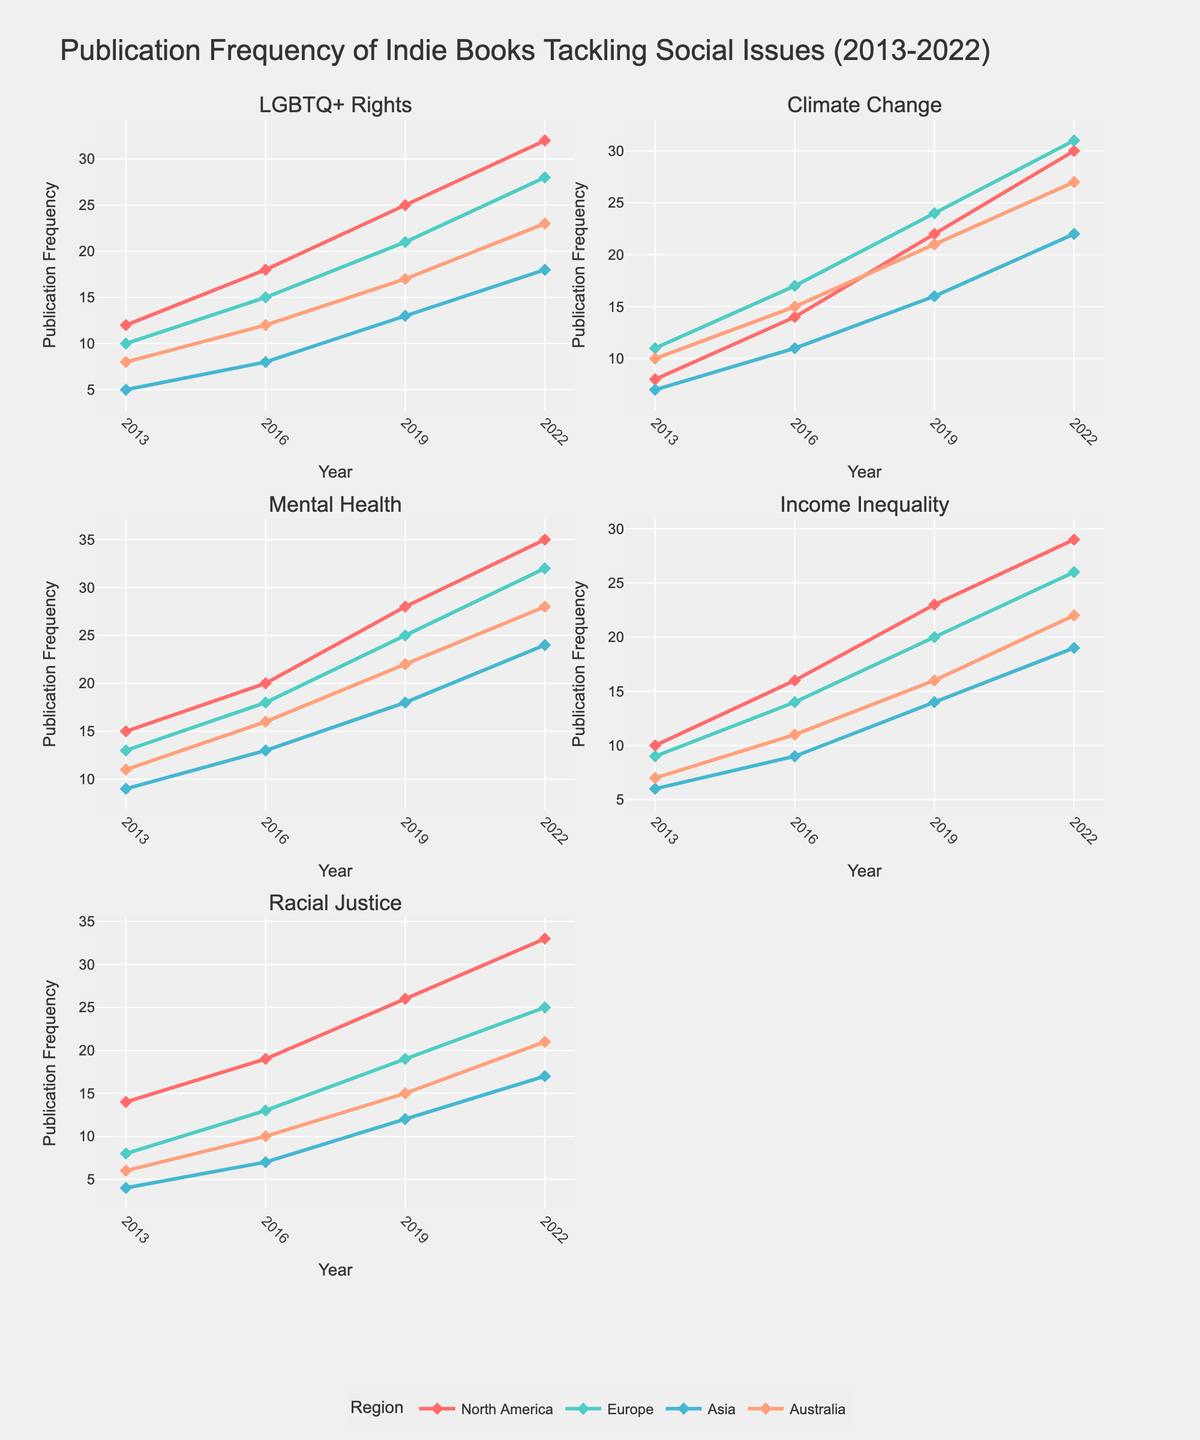What is the title of the figure? The title of the figure is typically located at the top of the visualization and is a text element summarizing the content or purpose. In this case, we can see "Publication Frequency of Indie Books Tackling Social Issues (2013-2022)" at the top.
Answer: Publication Frequency of Indie Books Tackling Social Issues (2013-2022) How many social issues are analyzed in this figure? Each subplot in the grid represents one social issue. There are five subplot titles, each corresponding to a specific social issue.
Answer: 5 Which region had the highest publication frequency for Mental Health books in 2019? By looking at the subplot for Mental Health and observing the lines for different regions, the highest value in 2019 is represented by North America.
Answer: North America By how much did the publication frequency of Climate Change books increase for North America from 2013 to 2022? Identify the start and end values for North America in the Climate Change subplot. In 2013, the value is 8, and in 2022, it is 30. The increase is 30 - 8.
Answer: 22 Which social issue saw the least growth in publications in Asia from 2013 to 2022? By comparing the trends for each social issue in the Asia region, Mental Health started at 9 in 2013 and grew to 24 in 2022. Climate Change grew from 7 to 22, a smaller increase. Racial Justice climbed from 4 to 17, an increase of 13, which is the smallest growth.
Answer: Racial Justice What is the average publication frequency for LGBTQ+ Rights books in Europe over the years 2013, 2016, 2019, and 2022? Sum up the publication frequencies for these years: 10 (2013) + 15 (2016) + 21 (2019) + 28 (2022) = 74. Then divide by 4 (the number of years).
Answer: 18.5 Between Europe and Australia, which region shows a higher publication frequency for Income Inequality books in 2016? Compare the values in the Income Inequality subplot for both regions in the year 2016. Europe has 14, and Australia has 11.
Answer: Europe What is the overall trend in publications for Racial Justice books in North America from 2013 to 2022? Examine the line representing North America in the Racial Justice subplot. The line steadily increases from 14 (in 2013) to 33 (in 2022).
Answer: Increasing Did the publication frequency for LGBTQ+ Rights books in North America show continuous growth over the decade, 2013-2022? Check the values for North America in the LGBTQ+ Rights subplot across the years. They increase from 12 (2013) to 18 (2016), 25 (2019), and 32 (2022), showing continuous growth.
Answer: Yes Which region had the maximum publication frequency for any issue in 2022, and what was the issue? Look for the highest data point in 2022 across all subplots. The highest frequency in 2022 is for Mental Health in North America with a value of 35.
Answer: North America, Mental Health 